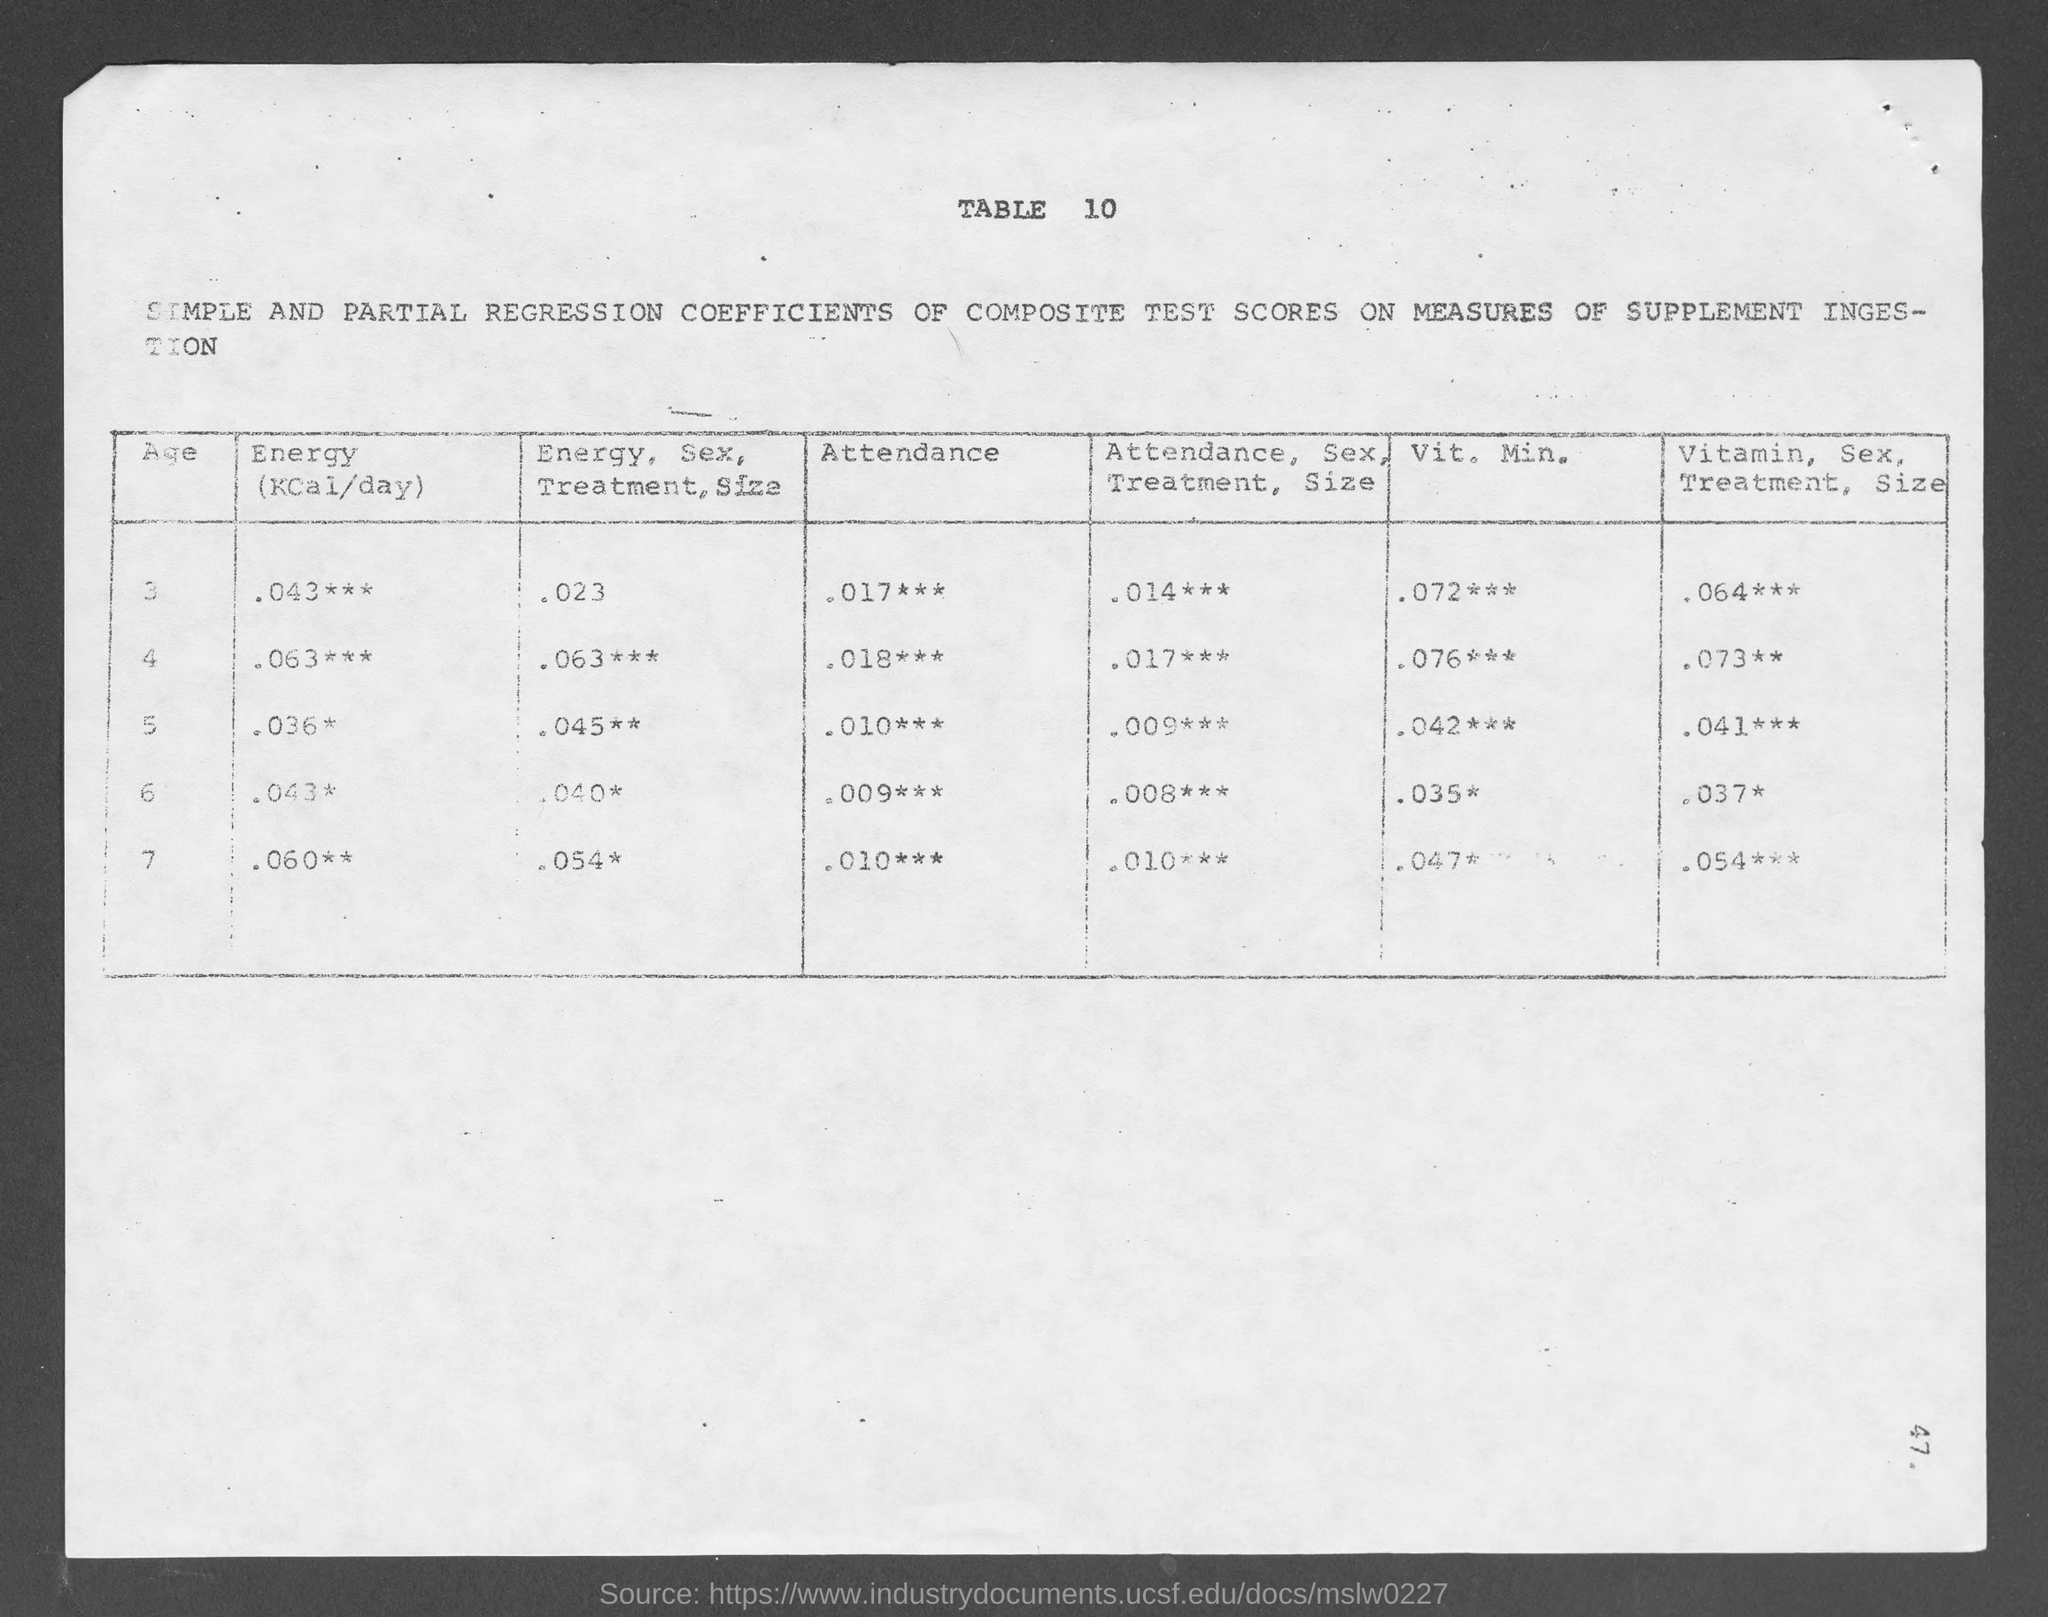What can you infer about the document's purpose? Based on the focus on regression coefficients and test scores related to supplement ingestion, the document appears to be a research paper or study results examining the effects of nutritional supplements on certain variables, like energy intake and attendance, potentially in a specific population, sorted by age. 